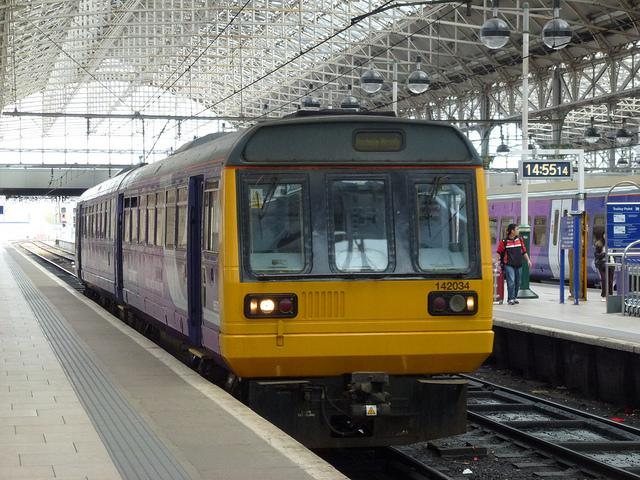What session of the day is shown in the photo?

Choices:
A) dawn
B) afternoon
C) morning
D) evening afternoon 